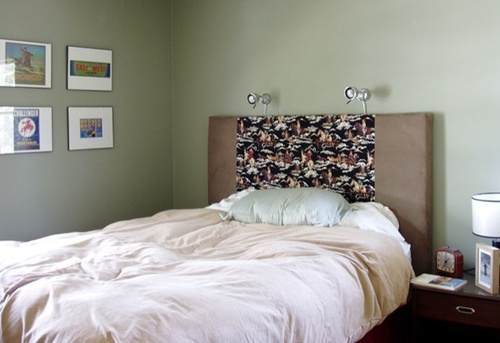Describe the objects in this image and their specific colors. I can see bed in gray, lightgray, and darkgray tones and clock in gray, black, darkgray, and maroon tones in this image. 